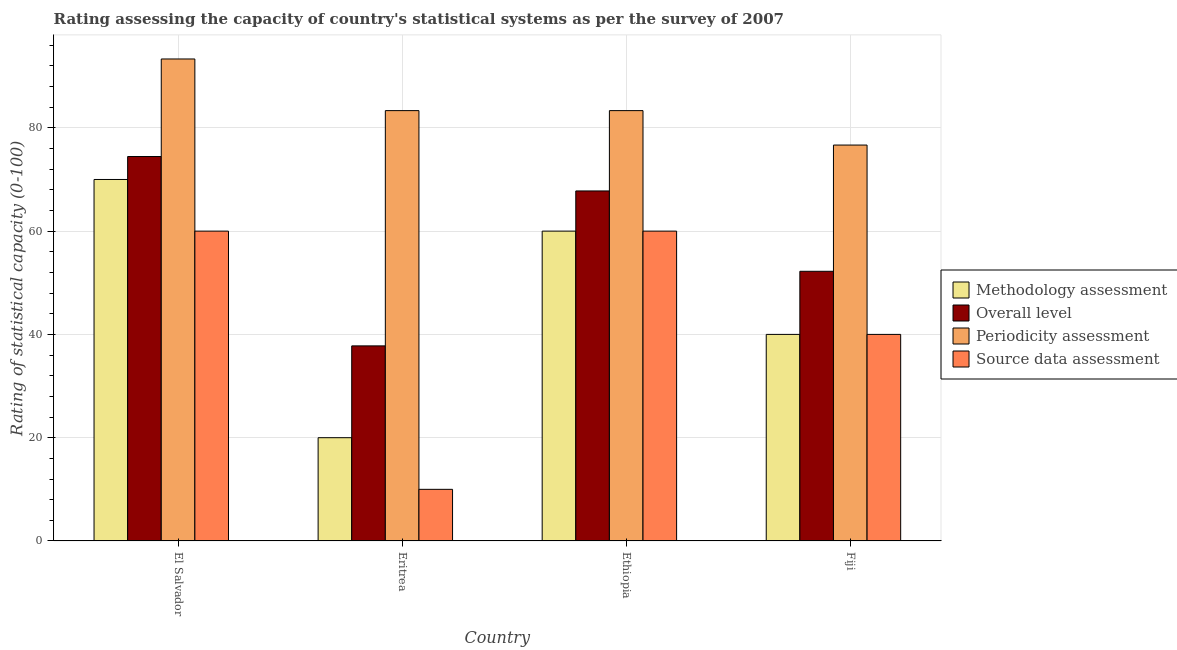How many groups of bars are there?
Make the answer very short. 4. Are the number of bars per tick equal to the number of legend labels?
Provide a short and direct response. Yes. How many bars are there on the 4th tick from the left?
Make the answer very short. 4. What is the label of the 3rd group of bars from the left?
Your answer should be very brief. Ethiopia. In how many cases, is the number of bars for a given country not equal to the number of legend labels?
Your response must be concise. 0. Across all countries, what is the maximum overall level rating?
Keep it short and to the point. 74.44. In which country was the periodicity assessment rating maximum?
Offer a terse response. El Salvador. In which country was the methodology assessment rating minimum?
Keep it short and to the point. Eritrea. What is the total source data assessment rating in the graph?
Your answer should be compact. 170. What is the difference between the overall level rating in El Salvador and that in Ethiopia?
Your response must be concise. 6.67. What is the difference between the source data assessment rating in Fiji and the periodicity assessment rating in Eritrea?
Make the answer very short. -43.33. What is the average methodology assessment rating per country?
Your response must be concise. 47.5. What is the difference between the periodicity assessment rating and overall level rating in Fiji?
Offer a very short reply. 24.44. In how many countries, is the overall level rating greater than 40 ?
Make the answer very short. 3. What is the ratio of the methodology assessment rating in El Salvador to that in Fiji?
Your answer should be compact. 1.75. What is the difference between the highest and the lowest methodology assessment rating?
Offer a terse response. 50. In how many countries, is the source data assessment rating greater than the average source data assessment rating taken over all countries?
Give a very brief answer. 2. Is the sum of the overall level rating in Ethiopia and Fiji greater than the maximum periodicity assessment rating across all countries?
Offer a very short reply. Yes. Is it the case that in every country, the sum of the periodicity assessment rating and overall level rating is greater than the sum of source data assessment rating and methodology assessment rating?
Ensure brevity in your answer.  Yes. What does the 2nd bar from the left in Ethiopia represents?
Provide a succinct answer. Overall level. What does the 4th bar from the right in El Salvador represents?
Give a very brief answer. Methodology assessment. How many bars are there?
Offer a very short reply. 16. What is the difference between two consecutive major ticks on the Y-axis?
Make the answer very short. 20. Are the values on the major ticks of Y-axis written in scientific E-notation?
Ensure brevity in your answer.  No. Does the graph contain any zero values?
Offer a very short reply. No. Does the graph contain grids?
Give a very brief answer. Yes. How many legend labels are there?
Make the answer very short. 4. What is the title of the graph?
Provide a succinct answer. Rating assessing the capacity of country's statistical systems as per the survey of 2007 . Does "Secondary vocational education" appear as one of the legend labels in the graph?
Your answer should be very brief. No. What is the label or title of the Y-axis?
Provide a short and direct response. Rating of statistical capacity (0-100). What is the Rating of statistical capacity (0-100) in Methodology assessment in El Salvador?
Ensure brevity in your answer.  70. What is the Rating of statistical capacity (0-100) in Overall level in El Salvador?
Keep it short and to the point. 74.44. What is the Rating of statistical capacity (0-100) in Periodicity assessment in El Salvador?
Keep it short and to the point. 93.33. What is the Rating of statistical capacity (0-100) in Methodology assessment in Eritrea?
Provide a short and direct response. 20. What is the Rating of statistical capacity (0-100) of Overall level in Eritrea?
Your answer should be compact. 37.78. What is the Rating of statistical capacity (0-100) in Periodicity assessment in Eritrea?
Offer a very short reply. 83.33. What is the Rating of statistical capacity (0-100) in Source data assessment in Eritrea?
Offer a very short reply. 10. What is the Rating of statistical capacity (0-100) of Overall level in Ethiopia?
Ensure brevity in your answer.  67.78. What is the Rating of statistical capacity (0-100) of Periodicity assessment in Ethiopia?
Your response must be concise. 83.33. What is the Rating of statistical capacity (0-100) in Methodology assessment in Fiji?
Provide a short and direct response. 40. What is the Rating of statistical capacity (0-100) of Overall level in Fiji?
Offer a terse response. 52.22. What is the Rating of statistical capacity (0-100) in Periodicity assessment in Fiji?
Your response must be concise. 76.67. What is the Rating of statistical capacity (0-100) of Source data assessment in Fiji?
Give a very brief answer. 40. Across all countries, what is the maximum Rating of statistical capacity (0-100) in Methodology assessment?
Give a very brief answer. 70. Across all countries, what is the maximum Rating of statistical capacity (0-100) of Overall level?
Your answer should be very brief. 74.44. Across all countries, what is the maximum Rating of statistical capacity (0-100) in Periodicity assessment?
Offer a very short reply. 93.33. Across all countries, what is the maximum Rating of statistical capacity (0-100) of Source data assessment?
Offer a very short reply. 60. Across all countries, what is the minimum Rating of statistical capacity (0-100) in Methodology assessment?
Ensure brevity in your answer.  20. Across all countries, what is the minimum Rating of statistical capacity (0-100) in Overall level?
Provide a short and direct response. 37.78. Across all countries, what is the minimum Rating of statistical capacity (0-100) of Periodicity assessment?
Give a very brief answer. 76.67. Across all countries, what is the minimum Rating of statistical capacity (0-100) of Source data assessment?
Your answer should be very brief. 10. What is the total Rating of statistical capacity (0-100) in Methodology assessment in the graph?
Ensure brevity in your answer.  190. What is the total Rating of statistical capacity (0-100) of Overall level in the graph?
Offer a very short reply. 232.22. What is the total Rating of statistical capacity (0-100) in Periodicity assessment in the graph?
Ensure brevity in your answer.  336.67. What is the total Rating of statistical capacity (0-100) in Source data assessment in the graph?
Your answer should be compact. 170. What is the difference between the Rating of statistical capacity (0-100) of Methodology assessment in El Salvador and that in Eritrea?
Give a very brief answer. 50. What is the difference between the Rating of statistical capacity (0-100) of Overall level in El Salvador and that in Eritrea?
Make the answer very short. 36.67. What is the difference between the Rating of statistical capacity (0-100) of Periodicity assessment in El Salvador and that in Eritrea?
Provide a short and direct response. 10. What is the difference between the Rating of statistical capacity (0-100) of Methodology assessment in El Salvador and that in Ethiopia?
Keep it short and to the point. 10. What is the difference between the Rating of statistical capacity (0-100) in Overall level in El Salvador and that in Ethiopia?
Offer a very short reply. 6.67. What is the difference between the Rating of statistical capacity (0-100) in Periodicity assessment in El Salvador and that in Ethiopia?
Keep it short and to the point. 10. What is the difference between the Rating of statistical capacity (0-100) of Methodology assessment in El Salvador and that in Fiji?
Provide a short and direct response. 30. What is the difference between the Rating of statistical capacity (0-100) in Overall level in El Salvador and that in Fiji?
Your answer should be very brief. 22.22. What is the difference between the Rating of statistical capacity (0-100) in Periodicity assessment in El Salvador and that in Fiji?
Offer a very short reply. 16.67. What is the difference between the Rating of statistical capacity (0-100) in Methodology assessment in Eritrea and that in Ethiopia?
Give a very brief answer. -40. What is the difference between the Rating of statistical capacity (0-100) in Periodicity assessment in Eritrea and that in Ethiopia?
Your answer should be compact. 0. What is the difference between the Rating of statistical capacity (0-100) of Methodology assessment in Eritrea and that in Fiji?
Offer a very short reply. -20. What is the difference between the Rating of statistical capacity (0-100) in Overall level in Eritrea and that in Fiji?
Your answer should be compact. -14.44. What is the difference between the Rating of statistical capacity (0-100) of Periodicity assessment in Eritrea and that in Fiji?
Your response must be concise. 6.67. What is the difference between the Rating of statistical capacity (0-100) in Overall level in Ethiopia and that in Fiji?
Make the answer very short. 15.56. What is the difference between the Rating of statistical capacity (0-100) in Source data assessment in Ethiopia and that in Fiji?
Offer a terse response. 20. What is the difference between the Rating of statistical capacity (0-100) of Methodology assessment in El Salvador and the Rating of statistical capacity (0-100) of Overall level in Eritrea?
Make the answer very short. 32.22. What is the difference between the Rating of statistical capacity (0-100) of Methodology assessment in El Salvador and the Rating of statistical capacity (0-100) of Periodicity assessment in Eritrea?
Keep it short and to the point. -13.33. What is the difference between the Rating of statistical capacity (0-100) in Overall level in El Salvador and the Rating of statistical capacity (0-100) in Periodicity assessment in Eritrea?
Offer a very short reply. -8.89. What is the difference between the Rating of statistical capacity (0-100) of Overall level in El Salvador and the Rating of statistical capacity (0-100) of Source data assessment in Eritrea?
Provide a short and direct response. 64.44. What is the difference between the Rating of statistical capacity (0-100) in Periodicity assessment in El Salvador and the Rating of statistical capacity (0-100) in Source data assessment in Eritrea?
Provide a succinct answer. 83.33. What is the difference between the Rating of statistical capacity (0-100) in Methodology assessment in El Salvador and the Rating of statistical capacity (0-100) in Overall level in Ethiopia?
Provide a succinct answer. 2.22. What is the difference between the Rating of statistical capacity (0-100) in Methodology assessment in El Salvador and the Rating of statistical capacity (0-100) in Periodicity assessment in Ethiopia?
Give a very brief answer. -13.33. What is the difference between the Rating of statistical capacity (0-100) of Methodology assessment in El Salvador and the Rating of statistical capacity (0-100) of Source data assessment in Ethiopia?
Your response must be concise. 10. What is the difference between the Rating of statistical capacity (0-100) in Overall level in El Salvador and the Rating of statistical capacity (0-100) in Periodicity assessment in Ethiopia?
Offer a terse response. -8.89. What is the difference between the Rating of statistical capacity (0-100) in Overall level in El Salvador and the Rating of statistical capacity (0-100) in Source data assessment in Ethiopia?
Make the answer very short. 14.44. What is the difference between the Rating of statistical capacity (0-100) of Periodicity assessment in El Salvador and the Rating of statistical capacity (0-100) of Source data assessment in Ethiopia?
Offer a very short reply. 33.33. What is the difference between the Rating of statistical capacity (0-100) in Methodology assessment in El Salvador and the Rating of statistical capacity (0-100) in Overall level in Fiji?
Make the answer very short. 17.78. What is the difference between the Rating of statistical capacity (0-100) in Methodology assessment in El Salvador and the Rating of statistical capacity (0-100) in Periodicity assessment in Fiji?
Ensure brevity in your answer.  -6.67. What is the difference between the Rating of statistical capacity (0-100) in Overall level in El Salvador and the Rating of statistical capacity (0-100) in Periodicity assessment in Fiji?
Offer a terse response. -2.22. What is the difference between the Rating of statistical capacity (0-100) of Overall level in El Salvador and the Rating of statistical capacity (0-100) of Source data assessment in Fiji?
Your response must be concise. 34.44. What is the difference between the Rating of statistical capacity (0-100) in Periodicity assessment in El Salvador and the Rating of statistical capacity (0-100) in Source data assessment in Fiji?
Your answer should be very brief. 53.33. What is the difference between the Rating of statistical capacity (0-100) in Methodology assessment in Eritrea and the Rating of statistical capacity (0-100) in Overall level in Ethiopia?
Make the answer very short. -47.78. What is the difference between the Rating of statistical capacity (0-100) of Methodology assessment in Eritrea and the Rating of statistical capacity (0-100) of Periodicity assessment in Ethiopia?
Give a very brief answer. -63.33. What is the difference between the Rating of statistical capacity (0-100) in Overall level in Eritrea and the Rating of statistical capacity (0-100) in Periodicity assessment in Ethiopia?
Provide a succinct answer. -45.56. What is the difference between the Rating of statistical capacity (0-100) of Overall level in Eritrea and the Rating of statistical capacity (0-100) of Source data assessment in Ethiopia?
Offer a very short reply. -22.22. What is the difference between the Rating of statistical capacity (0-100) of Periodicity assessment in Eritrea and the Rating of statistical capacity (0-100) of Source data assessment in Ethiopia?
Your answer should be very brief. 23.33. What is the difference between the Rating of statistical capacity (0-100) in Methodology assessment in Eritrea and the Rating of statistical capacity (0-100) in Overall level in Fiji?
Provide a short and direct response. -32.22. What is the difference between the Rating of statistical capacity (0-100) in Methodology assessment in Eritrea and the Rating of statistical capacity (0-100) in Periodicity assessment in Fiji?
Offer a very short reply. -56.67. What is the difference between the Rating of statistical capacity (0-100) in Methodology assessment in Eritrea and the Rating of statistical capacity (0-100) in Source data assessment in Fiji?
Your answer should be compact. -20. What is the difference between the Rating of statistical capacity (0-100) in Overall level in Eritrea and the Rating of statistical capacity (0-100) in Periodicity assessment in Fiji?
Provide a short and direct response. -38.89. What is the difference between the Rating of statistical capacity (0-100) in Overall level in Eritrea and the Rating of statistical capacity (0-100) in Source data assessment in Fiji?
Provide a short and direct response. -2.22. What is the difference between the Rating of statistical capacity (0-100) of Periodicity assessment in Eritrea and the Rating of statistical capacity (0-100) of Source data assessment in Fiji?
Provide a short and direct response. 43.33. What is the difference between the Rating of statistical capacity (0-100) in Methodology assessment in Ethiopia and the Rating of statistical capacity (0-100) in Overall level in Fiji?
Ensure brevity in your answer.  7.78. What is the difference between the Rating of statistical capacity (0-100) of Methodology assessment in Ethiopia and the Rating of statistical capacity (0-100) of Periodicity assessment in Fiji?
Offer a very short reply. -16.67. What is the difference between the Rating of statistical capacity (0-100) in Overall level in Ethiopia and the Rating of statistical capacity (0-100) in Periodicity assessment in Fiji?
Give a very brief answer. -8.89. What is the difference between the Rating of statistical capacity (0-100) in Overall level in Ethiopia and the Rating of statistical capacity (0-100) in Source data assessment in Fiji?
Provide a succinct answer. 27.78. What is the difference between the Rating of statistical capacity (0-100) of Periodicity assessment in Ethiopia and the Rating of statistical capacity (0-100) of Source data assessment in Fiji?
Your answer should be compact. 43.33. What is the average Rating of statistical capacity (0-100) in Methodology assessment per country?
Provide a short and direct response. 47.5. What is the average Rating of statistical capacity (0-100) in Overall level per country?
Ensure brevity in your answer.  58.06. What is the average Rating of statistical capacity (0-100) of Periodicity assessment per country?
Your response must be concise. 84.17. What is the average Rating of statistical capacity (0-100) of Source data assessment per country?
Your answer should be compact. 42.5. What is the difference between the Rating of statistical capacity (0-100) of Methodology assessment and Rating of statistical capacity (0-100) of Overall level in El Salvador?
Your answer should be very brief. -4.44. What is the difference between the Rating of statistical capacity (0-100) in Methodology assessment and Rating of statistical capacity (0-100) in Periodicity assessment in El Salvador?
Your answer should be compact. -23.33. What is the difference between the Rating of statistical capacity (0-100) of Methodology assessment and Rating of statistical capacity (0-100) of Source data assessment in El Salvador?
Your answer should be very brief. 10. What is the difference between the Rating of statistical capacity (0-100) in Overall level and Rating of statistical capacity (0-100) in Periodicity assessment in El Salvador?
Offer a very short reply. -18.89. What is the difference between the Rating of statistical capacity (0-100) in Overall level and Rating of statistical capacity (0-100) in Source data assessment in El Salvador?
Provide a succinct answer. 14.44. What is the difference between the Rating of statistical capacity (0-100) in Periodicity assessment and Rating of statistical capacity (0-100) in Source data assessment in El Salvador?
Your answer should be compact. 33.33. What is the difference between the Rating of statistical capacity (0-100) of Methodology assessment and Rating of statistical capacity (0-100) of Overall level in Eritrea?
Ensure brevity in your answer.  -17.78. What is the difference between the Rating of statistical capacity (0-100) of Methodology assessment and Rating of statistical capacity (0-100) of Periodicity assessment in Eritrea?
Offer a terse response. -63.33. What is the difference between the Rating of statistical capacity (0-100) of Methodology assessment and Rating of statistical capacity (0-100) of Source data assessment in Eritrea?
Offer a terse response. 10. What is the difference between the Rating of statistical capacity (0-100) of Overall level and Rating of statistical capacity (0-100) of Periodicity assessment in Eritrea?
Your answer should be very brief. -45.56. What is the difference between the Rating of statistical capacity (0-100) of Overall level and Rating of statistical capacity (0-100) of Source data assessment in Eritrea?
Your answer should be very brief. 27.78. What is the difference between the Rating of statistical capacity (0-100) in Periodicity assessment and Rating of statistical capacity (0-100) in Source data assessment in Eritrea?
Your answer should be compact. 73.33. What is the difference between the Rating of statistical capacity (0-100) in Methodology assessment and Rating of statistical capacity (0-100) in Overall level in Ethiopia?
Provide a succinct answer. -7.78. What is the difference between the Rating of statistical capacity (0-100) of Methodology assessment and Rating of statistical capacity (0-100) of Periodicity assessment in Ethiopia?
Make the answer very short. -23.33. What is the difference between the Rating of statistical capacity (0-100) in Overall level and Rating of statistical capacity (0-100) in Periodicity assessment in Ethiopia?
Your answer should be compact. -15.56. What is the difference between the Rating of statistical capacity (0-100) of Overall level and Rating of statistical capacity (0-100) of Source data assessment in Ethiopia?
Give a very brief answer. 7.78. What is the difference between the Rating of statistical capacity (0-100) of Periodicity assessment and Rating of statistical capacity (0-100) of Source data assessment in Ethiopia?
Your response must be concise. 23.33. What is the difference between the Rating of statistical capacity (0-100) of Methodology assessment and Rating of statistical capacity (0-100) of Overall level in Fiji?
Offer a terse response. -12.22. What is the difference between the Rating of statistical capacity (0-100) in Methodology assessment and Rating of statistical capacity (0-100) in Periodicity assessment in Fiji?
Make the answer very short. -36.67. What is the difference between the Rating of statistical capacity (0-100) of Overall level and Rating of statistical capacity (0-100) of Periodicity assessment in Fiji?
Your answer should be compact. -24.44. What is the difference between the Rating of statistical capacity (0-100) of Overall level and Rating of statistical capacity (0-100) of Source data assessment in Fiji?
Your answer should be very brief. 12.22. What is the difference between the Rating of statistical capacity (0-100) in Periodicity assessment and Rating of statistical capacity (0-100) in Source data assessment in Fiji?
Make the answer very short. 36.67. What is the ratio of the Rating of statistical capacity (0-100) of Overall level in El Salvador to that in Eritrea?
Make the answer very short. 1.97. What is the ratio of the Rating of statistical capacity (0-100) in Periodicity assessment in El Salvador to that in Eritrea?
Provide a short and direct response. 1.12. What is the ratio of the Rating of statistical capacity (0-100) of Overall level in El Salvador to that in Ethiopia?
Offer a terse response. 1.1. What is the ratio of the Rating of statistical capacity (0-100) of Periodicity assessment in El Salvador to that in Ethiopia?
Your response must be concise. 1.12. What is the ratio of the Rating of statistical capacity (0-100) of Overall level in El Salvador to that in Fiji?
Provide a succinct answer. 1.43. What is the ratio of the Rating of statistical capacity (0-100) of Periodicity assessment in El Salvador to that in Fiji?
Give a very brief answer. 1.22. What is the ratio of the Rating of statistical capacity (0-100) of Methodology assessment in Eritrea to that in Ethiopia?
Ensure brevity in your answer.  0.33. What is the ratio of the Rating of statistical capacity (0-100) of Overall level in Eritrea to that in Ethiopia?
Provide a succinct answer. 0.56. What is the ratio of the Rating of statistical capacity (0-100) in Periodicity assessment in Eritrea to that in Ethiopia?
Provide a short and direct response. 1. What is the ratio of the Rating of statistical capacity (0-100) of Source data assessment in Eritrea to that in Ethiopia?
Your response must be concise. 0.17. What is the ratio of the Rating of statistical capacity (0-100) of Methodology assessment in Eritrea to that in Fiji?
Keep it short and to the point. 0.5. What is the ratio of the Rating of statistical capacity (0-100) in Overall level in Eritrea to that in Fiji?
Offer a terse response. 0.72. What is the ratio of the Rating of statistical capacity (0-100) of Periodicity assessment in Eritrea to that in Fiji?
Make the answer very short. 1.09. What is the ratio of the Rating of statistical capacity (0-100) in Source data assessment in Eritrea to that in Fiji?
Your response must be concise. 0.25. What is the ratio of the Rating of statistical capacity (0-100) of Overall level in Ethiopia to that in Fiji?
Your response must be concise. 1.3. What is the ratio of the Rating of statistical capacity (0-100) of Periodicity assessment in Ethiopia to that in Fiji?
Provide a short and direct response. 1.09. What is the difference between the highest and the second highest Rating of statistical capacity (0-100) in Overall level?
Give a very brief answer. 6.67. What is the difference between the highest and the lowest Rating of statistical capacity (0-100) of Methodology assessment?
Give a very brief answer. 50. What is the difference between the highest and the lowest Rating of statistical capacity (0-100) of Overall level?
Give a very brief answer. 36.67. What is the difference between the highest and the lowest Rating of statistical capacity (0-100) in Periodicity assessment?
Make the answer very short. 16.67. What is the difference between the highest and the lowest Rating of statistical capacity (0-100) in Source data assessment?
Your answer should be compact. 50. 